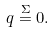Convert formula to latex. <formula><loc_0><loc_0><loc_500><loc_500>q \stackrel { \Sigma } { = } 0 .</formula> 